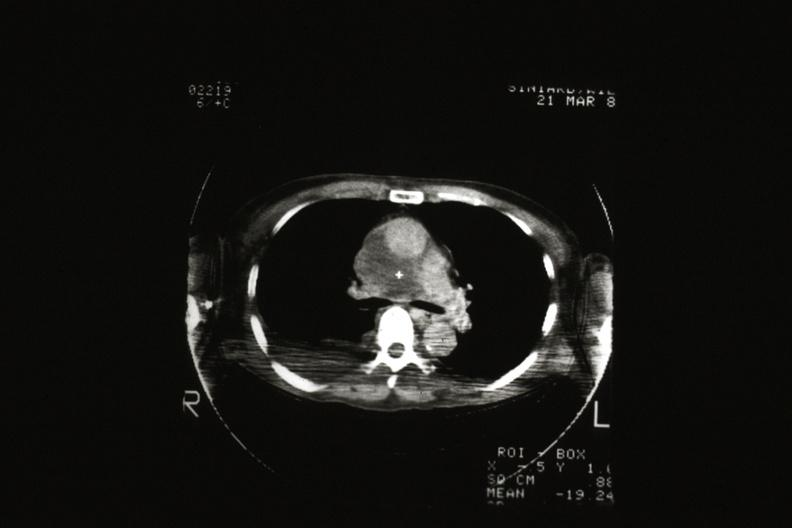what does cat scan?
Answer the question using a single word or phrase. Showing tumor invading superior vena ca 